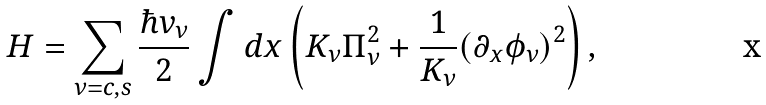<formula> <loc_0><loc_0><loc_500><loc_500>H = \sum _ { \nu = c , s } \frac { \hbar { v } _ { \nu } } { 2 } \int d x \left ( K _ { \nu } \Pi ^ { 2 } _ { \nu } + \frac { 1 } { K _ { \nu } } ( \partial _ { x } \phi _ { \nu } ) ^ { 2 } \right ) ,</formula> 